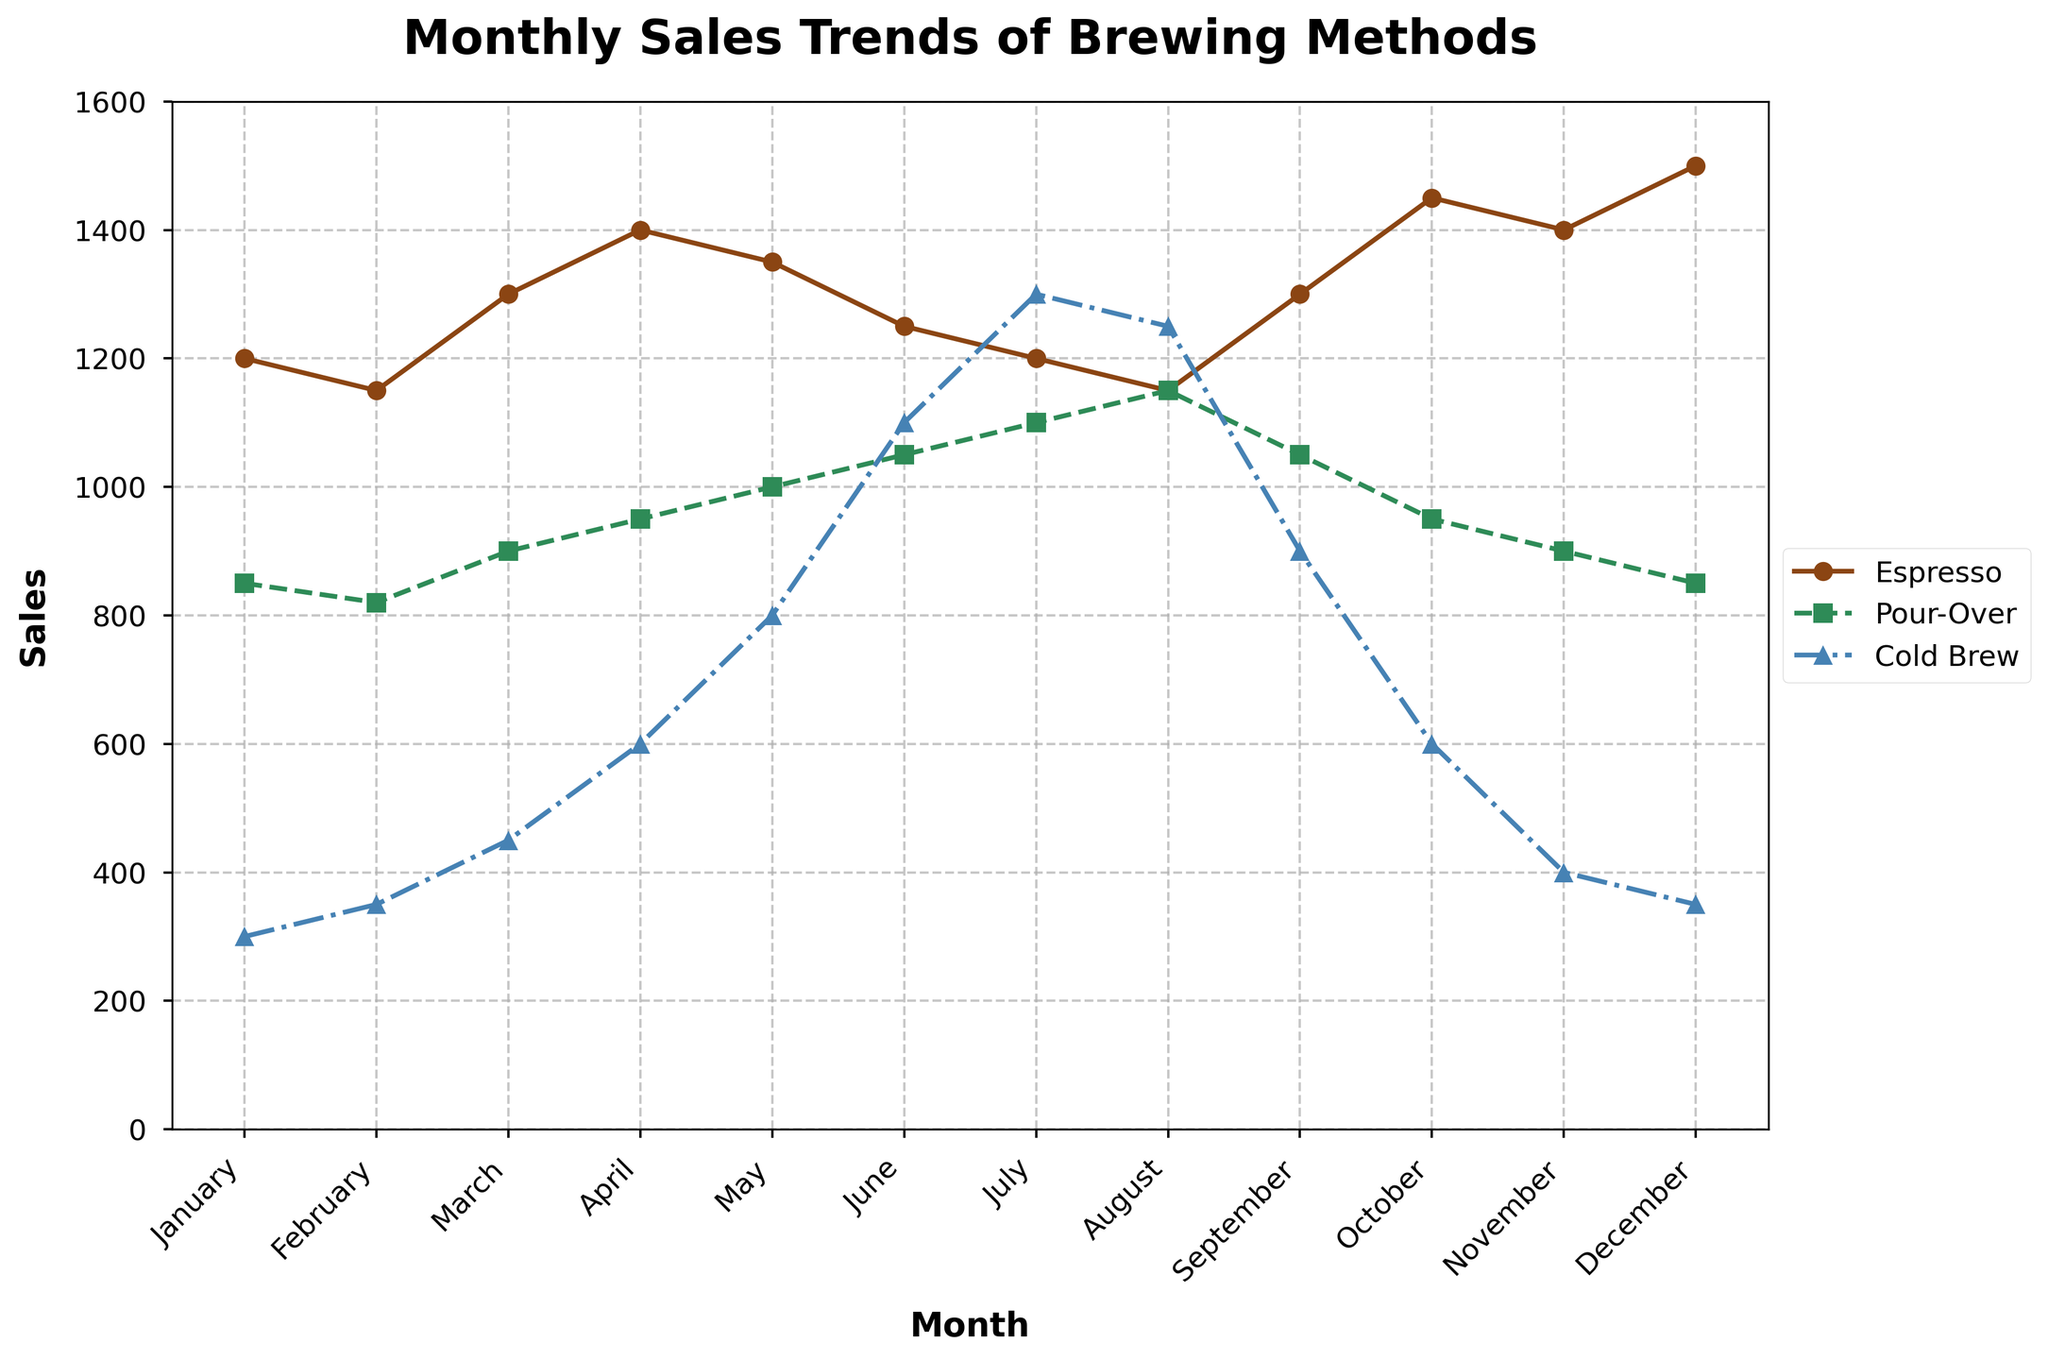What is the highest sales figure for Espresso in any month? From the figure, the highest point on the Espresso line corresponds to December with a sales figure of 1500.
Answer: 1500 Which brewing method had the lowest sales in July? Looking at July, the lowest point among all three lines is the Espresso line with sales of 1200.
Answer: Espresso In which month did Pour-Over sales surpass both Espresso and Cold Brew sales? August is the month where the Pour-Over line is higher than both Espresso and Cold Brew lines.
Answer: August What is the total sales of Cold Brew for the last three months (October, November, December)? Adding the Cold Brew sales for each of these months: 600 (October) + 400 (November) + 350 (December) = 1350.
Answer: 1350 Which month saw an increase in Cold Brew sales compared to the previous month by the largest margin? The largest single month-to-month increase in Cold Brew sales is from May to June, increasing from 800 to 1100, a difference of 300.
Answer: June What is the average sales figure for Pour-Over in the first quarter (January, February, March)? Sum the sales for January, February, and March: 850 + 820 + 900 = 2570. The average is then: 2570 / 3 ≈ 857.
Answer: 857 By looking at the trend, which brewing method has the most consistent sales throughout the year? By visual inspection, the Cold Brew line has fewer fluctuations compared to the other two methods, indicating more consistent sales.
Answer: Cold Brew How many months did Cold Brew sales exceed 1000? Cold Brew sales exceed 1000 in the months of June, July, and August, totaling 3 months.
Answer: 3 Which brewing method had the highest total sales across the entire year? Summing up the sales for each method: 
- Espresso: 1200+1150+1300+1400+1350+1250+1200+1150+1300+1450+1400+1500 = 15950 
- Pour-Over: 850+820+900+950+1000+1050+1100+1150+1050+950+900+850 = 11470 
- Cold Brew: 300+350+450+600+800+1100+1300+1250+900+600+400+350 = 8400 
Espresso has the highest total sales.
Answer: Espresso What is the difference in sales between the two brewing methods (Espresso and Pour-Over) in October? Espresso has 1450 sales in October, while Pour-Over has 950. The difference is 1450 - 950 = 500.
Answer: 500 